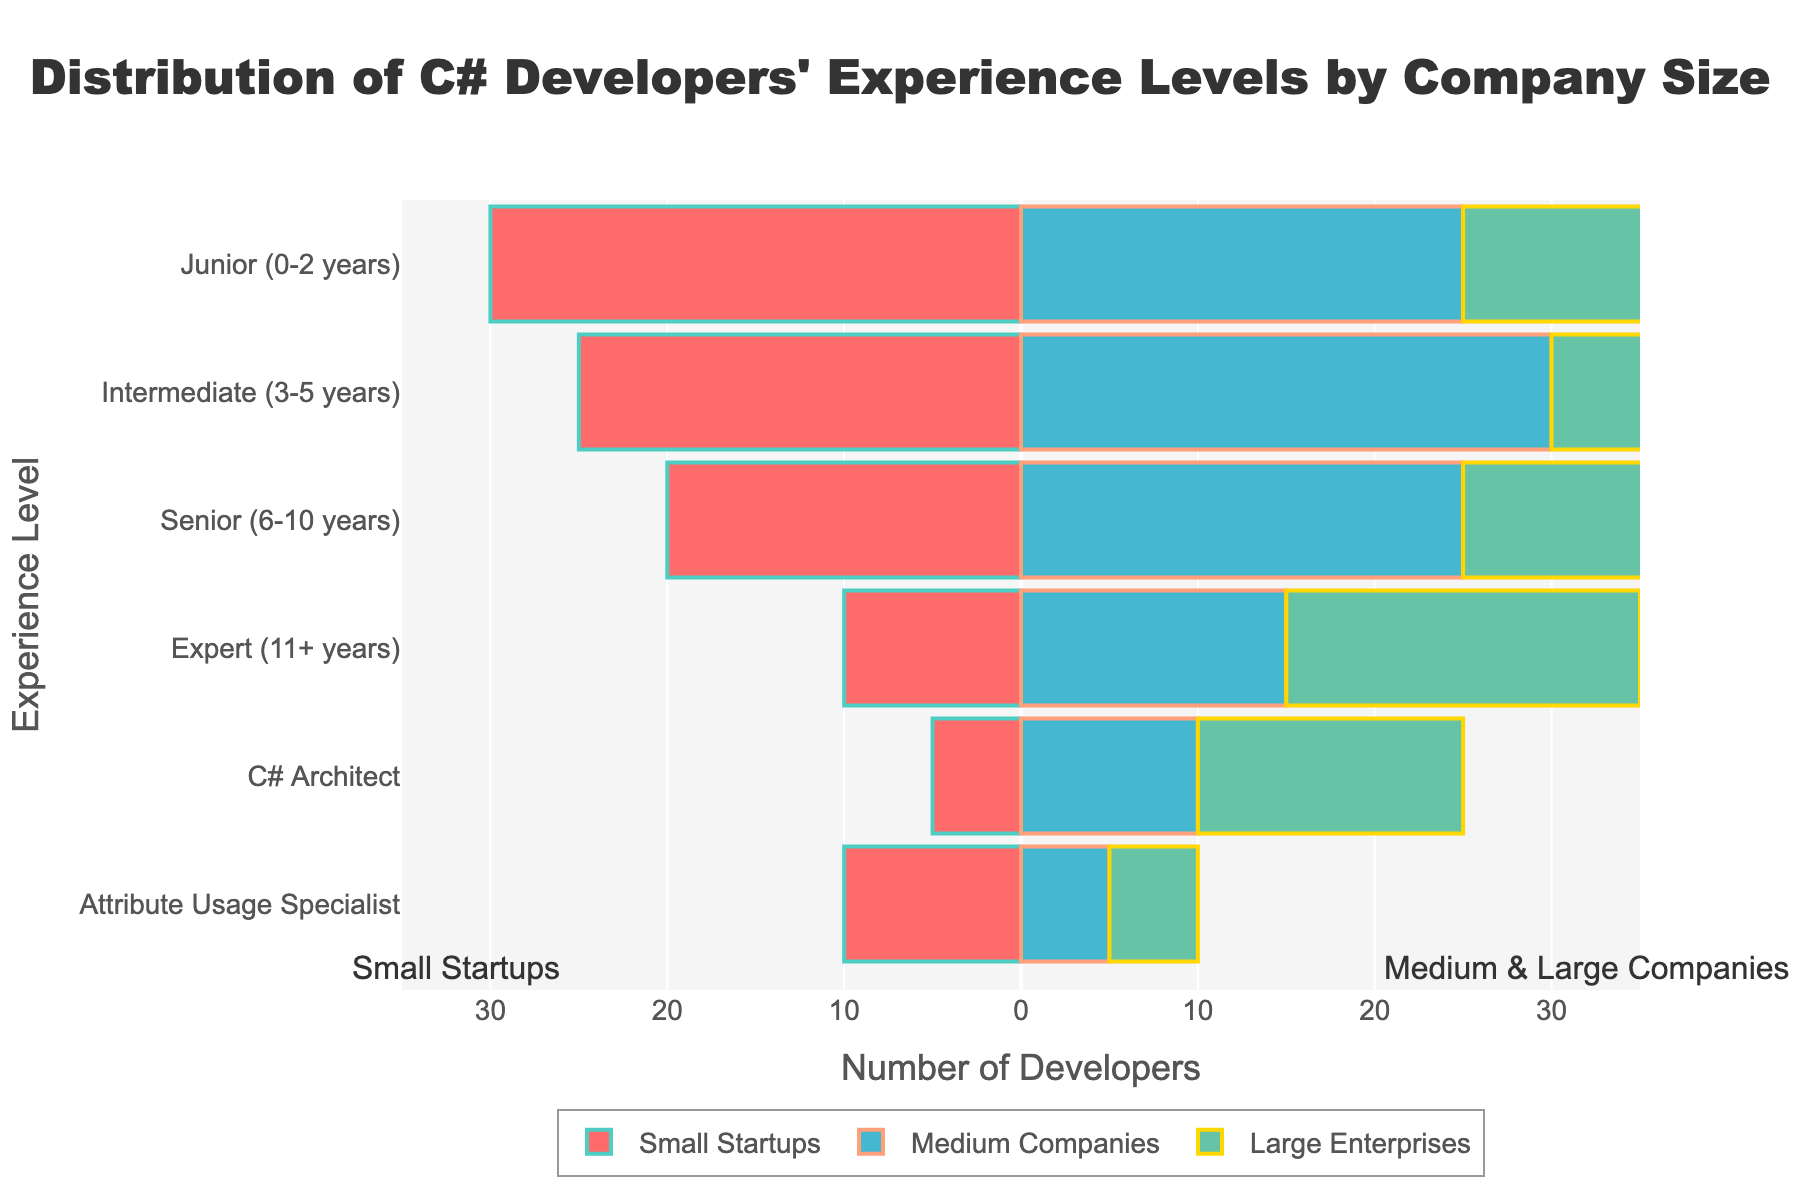How many C# developers with Junior experience levels are at Small Startups? Look at the bar labeled "Junior (0-2 years)" for the area marked "Small Startups" and read the number next to it.
Answer: 30 What is the total number of developers with Intermediate experience levels across all company sizes? Sum the count of Intermediate (3-5 years) developers in Small Startups, Medium Companies, and Large Enterprises: 25 (Small Startups) + 30 (Medium Companies) + 35 (Large Enterprises) = 90.
Answer: 90 Which company size has the highest number of developers categorized as C# Architects? Compare the bar lengths corresponding to "C# Architect" for all company sizes. The bar for "Large Enterprises" is the longest.
Answer: Large Enterprises How does the number of Expert developers compare between Medium Companies and Large Enterprises? Look at the bars for "Expert (11+ years)" in Medium Companies and Large Enterprises. Medium Companies have 15 developers, while Large Enterprises have 20. Therefore, Large Enterprises have more Expert developers.
Answer: More in Large Enterprises What is the difference in the number of Senior developers between Small Startups and Large Enterprises? Count the number of Senior (6-10 years) developers in Small Startups and Large Enterprises: 20 (Small Startups) and 30 (Large Enterprises). The difference is 30 - 20 = 10.
Answer: 10 Which experience level has the least number of developers in Medium Companies? Identify the smallest bar in the section for Medium Companies. The "Attribute Usage Specialist" experience level has the smallest bar, indicating 5 developers.
Answer: Attribute Usage Specialist What's the cumulative number of developers in Small Startups for the top three experience levels? Sum the developers for the top three levels in Small Startups: Junior (30), Intermediate (25), and Senior (20). The total is 30 + 25 + 20 = 75.
Answer: 75 Do Large Enterprises or Medium Companies have a greater number of Attribute Usage Specialists? Look at the bars for "Attribute Usage Specialist" in both Medium Companies and Large Enterprises. Medium Companies have 5 while Large Enterprises have 5 as well. Both are equal.
Answer: Equal How does the number of Junior developers at Small Startups compare to the number of Senior developers in Large Enterprises? Compare the length of the corresponding bars. Junior developers in Small Startups number 30, whereas Senior developers in Large Enterprises number 30. Both are equal.
Answer: Equal 